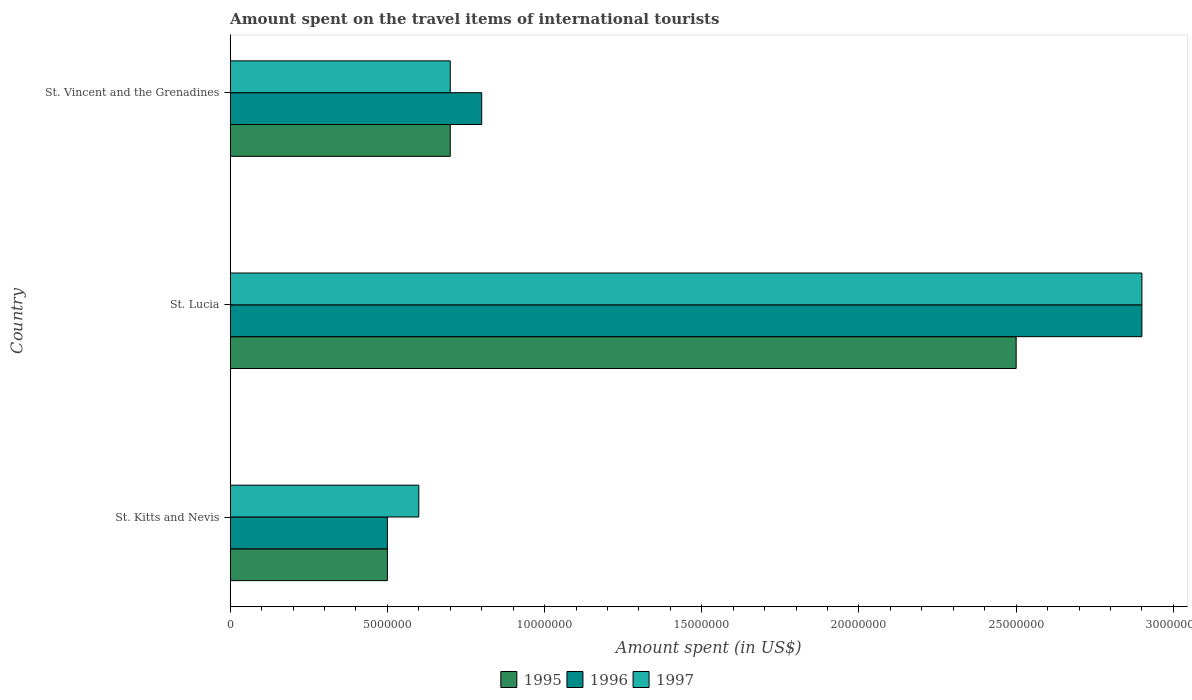How many bars are there on the 2nd tick from the bottom?
Your response must be concise. 3. What is the label of the 1st group of bars from the top?
Your response must be concise. St. Vincent and the Grenadines. In how many cases, is the number of bars for a given country not equal to the number of legend labels?
Make the answer very short. 0. What is the amount spent on the travel items of international tourists in 1997 in St. Lucia?
Provide a short and direct response. 2.90e+07. Across all countries, what is the maximum amount spent on the travel items of international tourists in 1995?
Provide a succinct answer. 2.50e+07. In which country was the amount spent on the travel items of international tourists in 1997 maximum?
Your response must be concise. St. Lucia. In which country was the amount spent on the travel items of international tourists in 1996 minimum?
Your answer should be compact. St. Kitts and Nevis. What is the total amount spent on the travel items of international tourists in 1997 in the graph?
Give a very brief answer. 4.20e+07. What is the difference between the amount spent on the travel items of international tourists in 1996 in St. Kitts and Nevis and that in St. Lucia?
Make the answer very short. -2.40e+07. What is the average amount spent on the travel items of international tourists in 1997 per country?
Offer a very short reply. 1.40e+07. What is the difference between the amount spent on the travel items of international tourists in 1995 and amount spent on the travel items of international tourists in 1997 in St. Vincent and the Grenadines?
Keep it short and to the point. 0. In how many countries, is the amount spent on the travel items of international tourists in 1995 greater than 7000000 US$?
Give a very brief answer. 1. What is the ratio of the amount spent on the travel items of international tourists in 1997 in St. Kitts and Nevis to that in St. Vincent and the Grenadines?
Offer a terse response. 0.86. What is the difference between the highest and the second highest amount spent on the travel items of international tourists in 1997?
Provide a succinct answer. 2.20e+07. What is the difference between the highest and the lowest amount spent on the travel items of international tourists in 1996?
Keep it short and to the point. 2.40e+07. What does the 1st bar from the bottom in St. Lucia represents?
Ensure brevity in your answer.  1995. What is the difference between two consecutive major ticks on the X-axis?
Your answer should be very brief. 5.00e+06. Does the graph contain grids?
Provide a succinct answer. No. Where does the legend appear in the graph?
Your answer should be very brief. Bottom center. How many legend labels are there?
Provide a succinct answer. 3. What is the title of the graph?
Make the answer very short. Amount spent on the travel items of international tourists. What is the label or title of the X-axis?
Offer a terse response. Amount spent (in US$). What is the label or title of the Y-axis?
Your response must be concise. Country. What is the Amount spent (in US$) of 1996 in St. Kitts and Nevis?
Ensure brevity in your answer.  5.00e+06. What is the Amount spent (in US$) of 1997 in St. Kitts and Nevis?
Keep it short and to the point. 6.00e+06. What is the Amount spent (in US$) of 1995 in St. Lucia?
Ensure brevity in your answer.  2.50e+07. What is the Amount spent (in US$) of 1996 in St. Lucia?
Your response must be concise. 2.90e+07. What is the Amount spent (in US$) of 1997 in St. Lucia?
Keep it short and to the point. 2.90e+07. What is the Amount spent (in US$) of 1996 in St. Vincent and the Grenadines?
Provide a succinct answer. 8.00e+06. What is the Amount spent (in US$) in 1997 in St. Vincent and the Grenadines?
Offer a terse response. 7.00e+06. Across all countries, what is the maximum Amount spent (in US$) in 1995?
Give a very brief answer. 2.50e+07. Across all countries, what is the maximum Amount spent (in US$) of 1996?
Your answer should be compact. 2.90e+07. Across all countries, what is the maximum Amount spent (in US$) of 1997?
Your answer should be compact. 2.90e+07. Across all countries, what is the minimum Amount spent (in US$) of 1995?
Offer a terse response. 5.00e+06. Across all countries, what is the minimum Amount spent (in US$) of 1996?
Provide a succinct answer. 5.00e+06. Across all countries, what is the minimum Amount spent (in US$) in 1997?
Your response must be concise. 6.00e+06. What is the total Amount spent (in US$) in 1995 in the graph?
Provide a short and direct response. 3.70e+07. What is the total Amount spent (in US$) in 1996 in the graph?
Ensure brevity in your answer.  4.20e+07. What is the total Amount spent (in US$) of 1997 in the graph?
Provide a short and direct response. 4.20e+07. What is the difference between the Amount spent (in US$) in 1995 in St. Kitts and Nevis and that in St. Lucia?
Offer a terse response. -2.00e+07. What is the difference between the Amount spent (in US$) of 1996 in St. Kitts and Nevis and that in St. Lucia?
Keep it short and to the point. -2.40e+07. What is the difference between the Amount spent (in US$) of 1997 in St. Kitts and Nevis and that in St. Lucia?
Give a very brief answer. -2.30e+07. What is the difference between the Amount spent (in US$) in 1996 in St. Kitts and Nevis and that in St. Vincent and the Grenadines?
Ensure brevity in your answer.  -3.00e+06. What is the difference between the Amount spent (in US$) of 1995 in St. Lucia and that in St. Vincent and the Grenadines?
Your answer should be compact. 1.80e+07. What is the difference between the Amount spent (in US$) of 1996 in St. Lucia and that in St. Vincent and the Grenadines?
Offer a very short reply. 2.10e+07. What is the difference between the Amount spent (in US$) of 1997 in St. Lucia and that in St. Vincent and the Grenadines?
Offer a very short reply. 2.20e+07. What is the difference between the Amount spent (in US$) in 1995 in St. Kitts and Nevis and the Amount spent (in US$) in 1996 in St. Lucia?
Keep it short and to the point. -2.40e+07. What is the difference between the Amount spent (in US$) of 1995 in St. Kitts and Nevis and the Amount spent (in US$) of 1997 in St. Lucia?
Make the answer very short. -2.40e+07. What is the difference between the Amount spent (in US$) of 1996 in St. Kitts and Nevis and the Amount spent (in US$) of 1997 in St. Lucia?
Keep it short and to the point. -2.40e+07. What is the difference between the Amount spent (in US$) of 1995 in St. Kitts and Nevis and the Amount spent (in US$) of 1997 in St. Vincent and the Grenadines?
Offer a very short reply. -2.00e+06. What is the difference between the Amount spent (in US$) in 1996 in St. Kitts and Nevis and the Amount spent (in US$) in 1997 in St. Vincent and the Grenadines?
Give a very brief answer. -2.00e+06. What is the difference between the Amount spent (in US$) in 1995 in St. Lucia and the Amount spent (in US$) in 1996 in St. Vincent and the Grenadines?
Provide a short and direct response. 1.70e+07. What is the difference between the Amount spent (in US$) in 1995 in St. Lucia and the Amount spent (in US$) in 1997 in St. Vincent and the Grenadines?
Make the answer very short. 1.80e+07. What is the difference between the Amount spent (in US$) in 1996 in St. Lucia and the Amount spent (in US$) in 1997 in St. Vincent and the Grenadines?
Offer a terse response. 2.20e+07. What is the average Amount spent (in US$) of 1995 per country?
Provide a short and direct response. 1.23e+07. What is the average Amount spent (in US$) in 1996 per country?
Offer a terse response. 1.40e+07. What is the average Amount spent (in US$) of 1997 per country?
Provide a succinct answer. 1.40e+07. What is the difference between the Amount spent (in US$) of 1995 and Amount spent (in US$) of 1997 in St. Kitts and Nevis?
Keep it short and to the point. -1.00e+06. What is the difference between the Amount spent (in US$) of 1995 and Amount spent (in US$) of 1996 in St. Lucia?
Your answer should be very brief. -4.00e+06. What is the difference between the Amount spent (in US$) in 1995 and Amount spent (in US$) in 1996 in St. Vincent and the Grenadines?
Your answer should be compact. -1.00e+06. What is the ratio of the Amount spent (in US$) in 1995 in St. Kitts and Nevis to that in St. Lucia?
Your answer should be compact. 0.2. What is the ratio of the Amount spent (in US$) of 1996 in St. Kitts and Nevis to that in St. Lucia?
Offer a terse response. 0.17. What is the ratio of the Amount spent (in US$) in 1997 in St. Kitts and Nevis to that in St. Lucia?
Provide a short and direct response. 0.21. What is the ratio of the Amount spent (in US$) in 1995 in St. Kitts and Nevis to that in St. Vincent and the Grenadines?
Your answer should be compact. 0.71. What is the ratio of the Amount spent (in US$) in 1996 in St. Kitts and Nevis to that in St. Vincent and the Grenadines?
Your response must be concise. 0.62. What is the ratio of the Amount spent (in US$) in 1997 in St. Kitts and Nevis to that in St. Vincent and the Grenadines?
Your response must be concise. 0.86. What is the ratio of the Amount spent (in US$) of 1995 in St. Lucia to that in St. Vincent and the Grenadines?
Your answer should be compact. 3.57. What is the ratio of the Amount spent (in US$) of 1996 in St. Lucia to that in St. Vincent and the Grenadines?
Give a very brief answer. 3.62. What is the ratio of the Amount spent (in US$) in 1997 in St. Lucia to that in St. Vincent and the Grenadines?
Your response must be concise. 4.14. What is the difference between the highest and the second highest Amount spent (in US$) of 1995?
Give a very brief answer. 1.80e+07. What is the difference between the highest and the second highest Amount spent (in US$) of 1996?
Your answer should be very brief. 2.10e+07. What is the difference between the highest and the second highest Amount spent (in US$) in 1997?
Your response must be concise. 2.20e+07. What is the difference between the highest and the lowest Amount spent (in US$) of 1996?
Provide a succinct answer. 2.40e+07. What is the difference between the highest and the lowest Amount spent (in US$) in 1997?
Ensure brevity in your answer.  2.30e+07. 